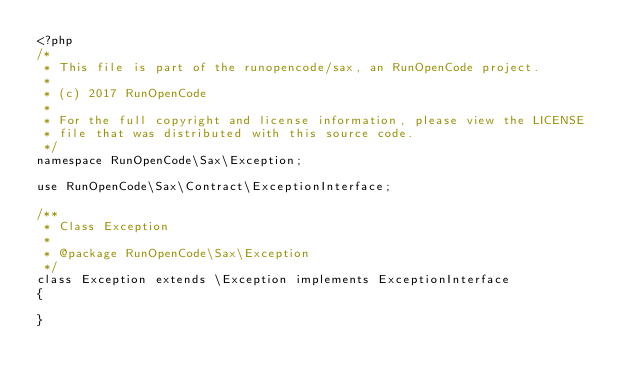<code> <loc_0><loc_0><loc_500><loc_500><_PHP_><?php
/*
 * This file is part of the runopencode/sax, an RunOpenCode project.
 *
 * (c) 2017 RunOpenCode
 *
 * For the full copyright and license information, please view the LICENSE
 * file that was distributed with this source code.
 */
namespace RunOpenCode\Sax\Exception;

use RunOpenCode\Sax\Contract\ExceptionInterface;

/**
 * Class Exception
 *
 * @package RunOpenCode\Sax\Exception
 */
class Exception extends \Exception implements ExceptionInterface
{

}
</code> 